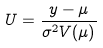Convert formula to latex. <formula><loc_0><loc_0><loc_500><loc_500>U = \frac { y - \mu } { \sigma ^ { 2 } V ( \mu ) }</formula> 